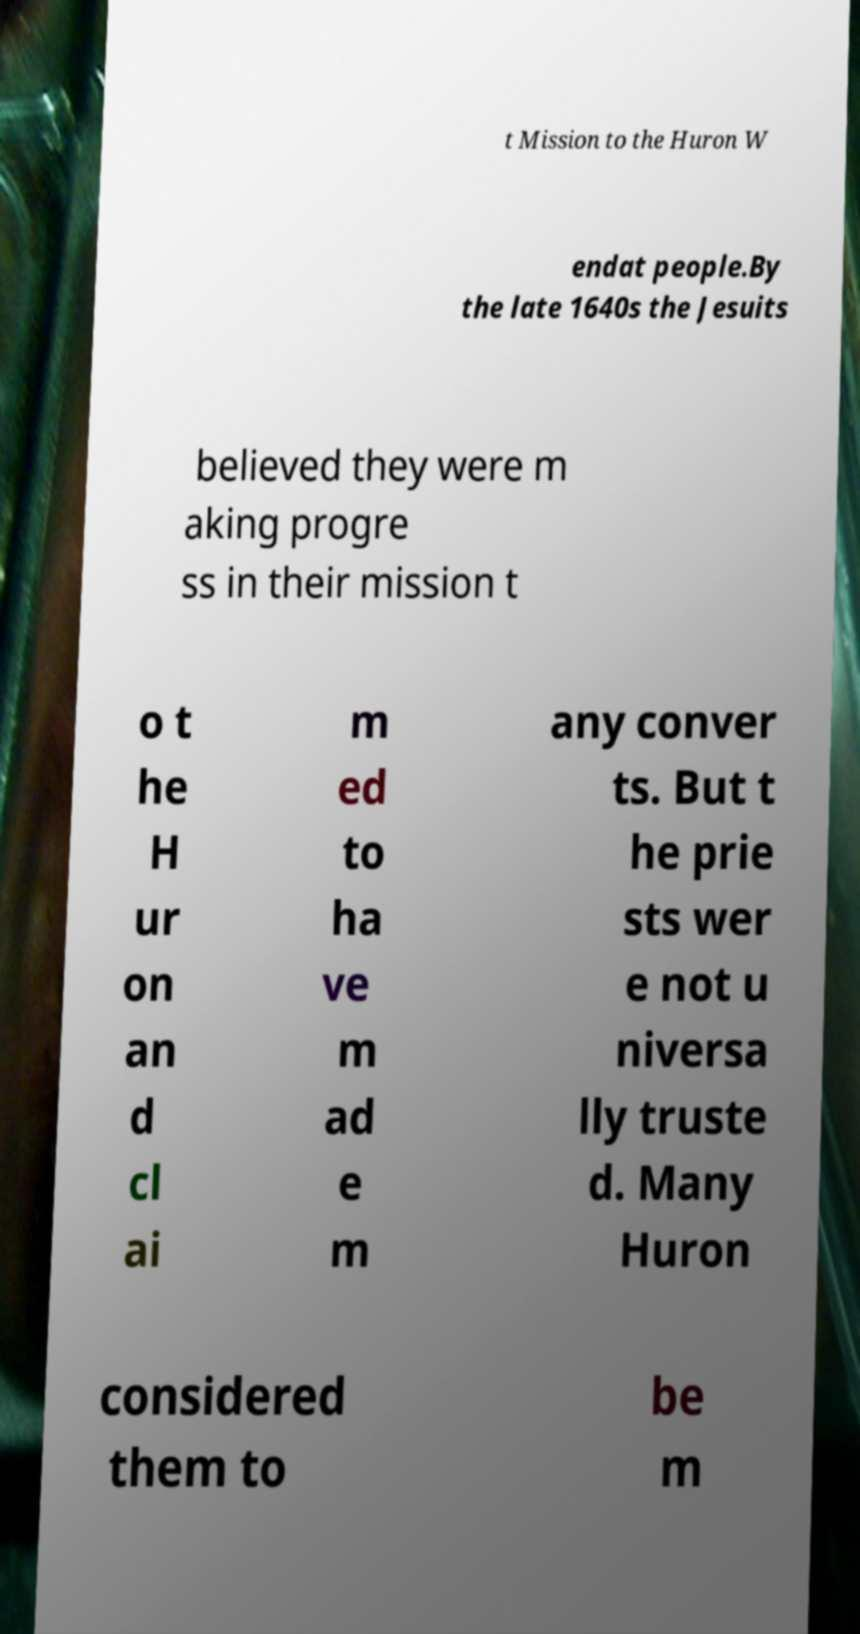Please identify and transcribe the text found in this image. t Mission to the Huron W endat people.By the late 1640s the Jesuits believed they were m aking progre ss in their mission t o t he H ur on an d cl ai m ed to ha ve m ad e m any conver ts. But t he prie sts wer e not u niversa lly truste d. Many Huron considered them to be m 